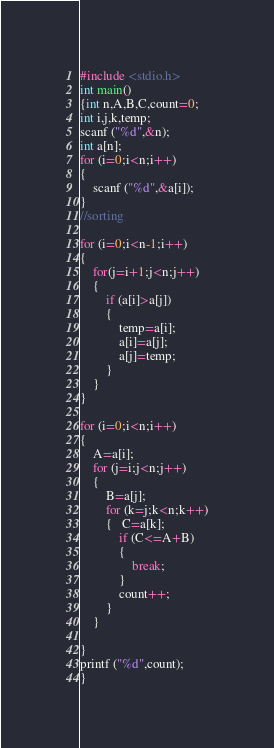Convert code to text. <code><loc_0><loc_0><loc_500><loc_500><_C_>#include <stdio.h>
int main()
{int n,A,B,C,count=0;
int i,j,k,temp;
scanf ("%d",&n);
int a[n];
for (i=0;i<n;i++)
{
    scanf ("%d",&a[i]);
}
//sorting

for (i=0;i<n-1;i++)
{
    for(j=i+1;j<n;j++)
    {
        if (a[i]>a[j])
        {
            temp=a[i];
            a[i]=a[j];
            a[j]=temp;
        }
    }
}

for (i=0;i<n;i++)
{ 
    A=a[i];
    for (j=i;j<n;j++)
    {
        B=a[j];
        for (k=j;k<n;k++)
        {   C=a[k];
            if (C<=A+B)
            {
                break;
            }
            count++;
        }
    }

}
printf ("%d",count);
}
</code> 